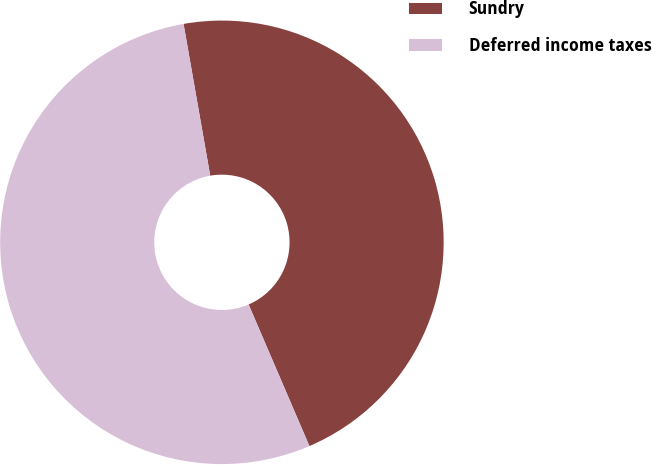<chart> <loc_0><loc_0><loc_500><loc_500><pie_chart><fcel>Sundry<fcel>Deferred income taxes<nl><fcel>46.31%<fcel>53.69%<nl></chart> 